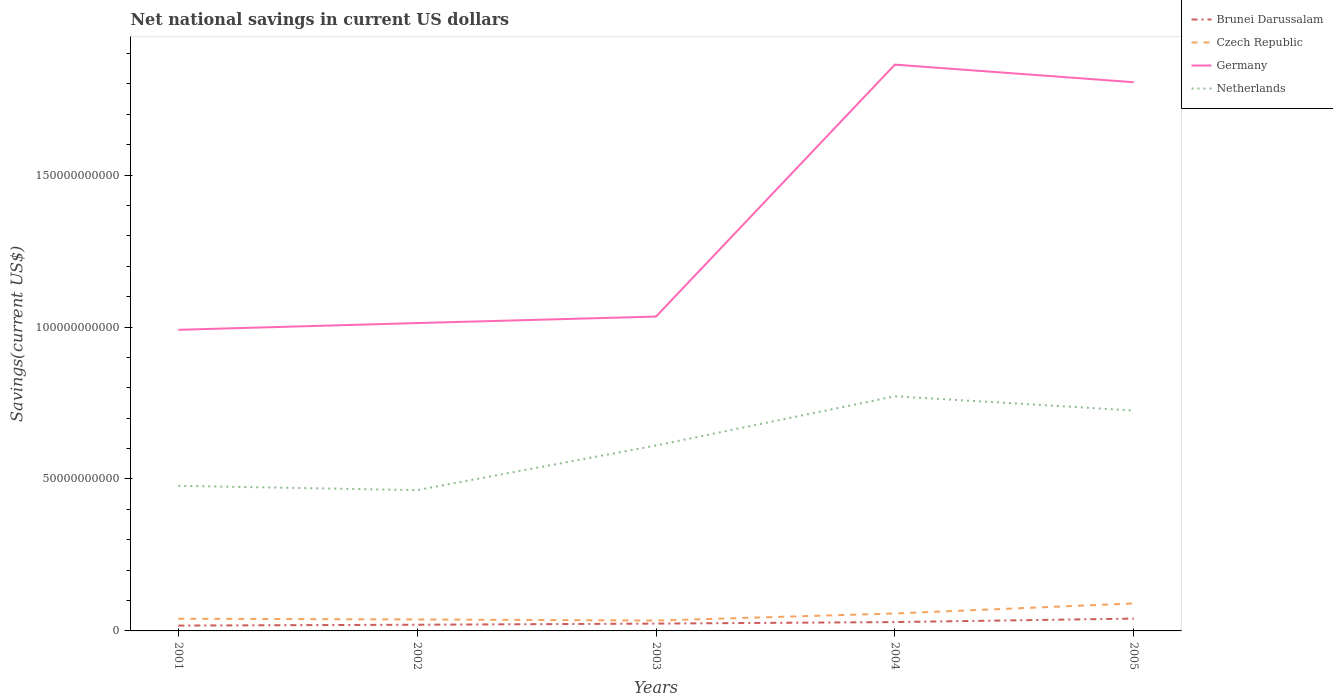Is the number of lines equal to the number of legend labels?
Ensure brevity in your answer.  Yes. Across all years, what is the maximum net national savings in Czech Republic?
Offer a very short reply. 3.42e+09. What is the total net national savings in Czech Republic in the graph?
Provide a short and direct response. 5.85e+08. What is the difference between the highest and the second highest net national savings in Czech Republic?
Keep it short and to the point. 5.63e+09. How many lines are there?
Your answer should be compact. 4. Where does the legend appear in the graph?
Provide a short and direct response. Top right. How are the legend labels stacked?
Your response must be concise. Vertical. What is the title of the graph?
Your answer should be very brief. Net national savings in current US dollars. What is the label or title of the X-axis?
Your answer should be very brief. Years. What is the label or title of the Y-axis?
Make the answer very short. Savings(current US$). What is the Savings(current US$) in Brunei Darussalam in 2001?
Make the answer very short. 1.76e+09. What is the Savings(current US$) of Czech Republic in 2001?
Provide a succinct answer. 4.00e+09. What is the Savings(current US$) of Germany in 2001?
Offer a very short reply. 9.91e+1. What is the Savings(current US$) of Netherlands in 2001?
Keep it short and to the point. 4.77e+1. What is the Savings(current US$) of Brunei Darussalam in 2002?
Provide a short and direct response. 2.04e+09. What is the Savings(current US$) in Czech Republic in 2002?
Make the answer very short. 3.78e+09. What is the Savings(current US$) of Germany in 2002?
Keep it short and to the point. 1.01e+11. What is the Savings(current US$) of Netherlands in 2002?
Offer a terse response. 4.63e+1. What is the Savings(current US$) in Brunei Darussalam in 2003?
Your answer should be compact. 2.41e+09. What is the Savings(current US$) in Czech Republic in 2003?
Offer a terse response. 3.42e+09. What is the Savings(current US$) in Germany in 2003?
Offer a very short reply. 1.03e+11. What is the Savings(current US$) in Netherlands in 2003?
Ensure brevity in your answer.  6.10e+1. What is the Savings(current US$) of Brunei Darussalam in 2004?
Keep it short and to the point. 2.91e+09. What is the Savings(current US$) of Czech Republic in 2004?
Provide a succinct answer. 5.74e+09. What is the Savings(current US$) in Germany in 2004?
Ensure brevity in your answer.  1.86e+11. What is the Savings(current US$) in Netherlands in 2004?
Make the answer very short. 7.72e+1. What is the Savings(current US$) in Brunei Darussalam in 2005?
Your response must be concise. 4.06e+09. What is the Savings(current US$) of Czech Republic in 2005?
Give a very brief answer. 9.04e+09. What is the Savings(current US$) in Germany in 2005?
Make the answer very short. 1.81e+11. What is the Savings(current US$) in Netherlands in 2005?
Give a very brief answer. 7.25e+1. Across all years, what is the maximum Savings(current US$) in Brunei Darussalam?
Keep it short and to the point. 4.06e+09. Across all years, what is the maximum Savings(current US$) in Czech Republic?
Offer a very short reply. 9.04e+09. Across all years, what is the maximum Savings(current US$) of Germany?
Offer a terse response. 1.86e+11. Across all years, what is the maximum Savings(current US$) in Netherlands?
Your answer should be very brief. 7.72e+1. Across all years, what is the minimum Savings(current US$) in Brunei Darussalam?
Make the answer very short. 1.76e+09. Across all years, what is the minimum Savings(current US$) of Czech Republic?
Give a very brief answer. 3.42e+09. Across all years, what is the minimum Savings(current US$) in Germany?
Give a very brief answer. 9.91e+1. Across all years, what is the minimum Savings(current US$) in Netherlands?
Your answer should be compact. 4.63e+1. What is the total Savings(current US$) in Brunei Darussalam in the graph?
Your answer should be compact. 1.32e+1. What is the total Savings(current US$) in Czech Republic in the graph?
Your response must be concise. 2.60e+1. What is the total Savings(current US$) of Germany in the graph?
Your answer should be very brief. 6.71e+11. What is the total Savings(current US$) of Netherlands in the graph?
Keep it short and to the point. 3.05e+11. What is the difference between the Savings(current US$) in Brunei Darussalam in 2001 and that in 2002?
Provide a short and direct response. -2.75e+08. What is the difference between the Savings(current US$) in Czech Republic in 2001 and that in 2002?
Provide a short and direct response. 2.19e+08. What is the difference between the Savings(current US$) of Germany in 2001 and that in 2002?
Your answer should be compact. -2.22e+09. What is the difference between the Savings(current US$) of Netherlands in 2001 and that in 2002?
Your answer should be very brief. 1.41e+09. What is the difference between the Savings(current US$) of Brunei Darussalam in 2001 and that in 2003?
Offer a terse response. -6.52e+08. What is the difference between the Savings(current US$) in Czech Republic in 2001 and that in 2003?
Offer a terse response. 5.85e+08. What is the difference between the Savings(current US$) in Germany in 2001 and that in 2003?
Offer a very short reply. -4.36e+09. What is the difference between the Savings(current US$) of Netherlands in 2001 and that in 2003?
Give a very brief answer. -1.33e+1. What is the difference between the Savings(current US$) in Brunei Darussalam in 2001 and that in 2004?
Your answer should be compact. -1.15e+09. What is the difference between the Savings(current US$) of Czech Republic in 2001 and that in 2004?
Offer a terse response. -1.74e+09. What is the difference between the Savings(current US$) in Germany in 2001 and that in 2004?
Your response must be concise. -8.73e+1. What is the difference between the Savings(current US$) of Netherlands in 2001 and that in 2004?
Your response must be concise. -2.95e+1. What is the difference between the Savings(current US$) in Brunei Darussalam in 2001 and that in 2005?
Provide a succinct answer. -2.30e+09. What is the difference between the Savings(current US$) in Czech Republic in 2001 and that in 2005?
Your response must be concise. -5.04e+09. What is the difference between the Savings(current US$) in Germany in 2001 and that in 2005?
Your answer should be very brief. -8.15e+1. What is the difference between the Savings(current US$) of Netherlands in 2001 and that in 2005?
Make the answer very short. -2.48e+1. What is the difference between the Savings(current US$) in Brunei Darussalam in 2002 and that in 2003?
Give a very brief answer. -3.77e+08. What is the difference between the Savings(current US$) in Czech Republic in 2002 and that in 2003?
Keep it short and to the point. 3.66e+08. What is the difference between the Savings(current US$) in Germany in 2002 and that in 2003?
Give a very brief answer. -2.14e+09. What is the difference between the Savings(current US$) of Netherlands in 2002 and that in 2003?
Offer a very short reply. -1.47e+1. What is the difference between the Savings(current US$) of Brunei Darussalam in 2002 and that in 2004?
Keep it short and to the point. -8.78e+08. What is the difference between the Savings(current US$) of Czech Republic in 2002 and that in 2004?
Offer a terse response. -1.96e+09. What is the difference between the Savings(current US$) in Germany in 2002 and that in 2004?
Keep it short and to the point. -8.50e+1. What is the difference between the Savings(current US$) in Netherlands in 2002 and that in 2004?
Provide a short and direct response. -3.09e+1. What is the difference between the Savings(current US$) in Brunei Darussalam in 2002 and that in 2005?
Offer a very short reply. -2.02e+09. What is the difference between the Savings(current US$) in Czech Republic in 2002 and that in 2005?
Make the answer very short. -5.26e+09. What is the difference between the Savings(current US$) in Germany in 2002 and that in 2005?
Ensure brevity in your answer.  -7.92e+1. What is the difference between the Savings(current US$) of Netherlands in 2002 and that in 2005?
Offer a very short reply. -2.62e+1. What is the difference between the Savings(current US$) of Brunei Darussalam in 2003 and that in 2004?
Provide a succinct answer. -5.01e+08. What is the difference between the Savings(current US$) in Czech Republic in 2003 and that in 2004?
Your answer should be very brief. -2.33e+09. What is the difference between the Savings(current US$) of Germany in 2003 and that in 2004?
Ensure brevity in your answer.  -8.29e+1. What is the difference between the Savings(current US$) of Netherlands in 2003 and that in 2004?
Provide a short and direct response. -1.62e+1. What is the difference between the Savings(current US$) of Brunei Darussalam in 2003 and that in 2005?
Offer a terse response. -1.64e+09. What is the difference between the Savings(current US$) in Czech Republic in 2003 and that in 2005?
Keep it short and to the point. -5.63e+09. What is the difference between the Savings(current US$) in Germany in 2003 and that in 2005?
Provide a short and direct response. -7.71e+1. What is the difference between the Savings(current US$) of Netherlands in 2003 and that in 2005?
Make the answer very short. -1.15e+1. What is the difference between the Savings(current US$) in Brunei Darussalam in 2004 and that in 2005?
Offer a terse response. -1.14e+09. What is the difference between the Savings(current US$) of Czech Republic in 2004 and that in 2005?
Keep it short and to the point. -3.30e+09. What is the difference between the Savings(current US$) in Germany in 2004 and that in 2005?
Your answer should be compact. 5.79e+09. What is the difference between the Savings(current US$) in Netherlands in 2004 and that in 2005?
Give a very brief answer. 4.68e+09. What is the difference between the Savings(current US$) of Brunei Darussalam in 2001 and the Savings(current US$) of Czech Republic in 2002?
Provide a succinct answer. -2.02e+09. What is the difference between the Savings(current US$) in Brunei Darussalam in 2001 and the Savings(current US$) in Germany in 2002?
Keep it short and to the point. -9.95e+1. What is the difference between the Savings(current US$) of Brunei Darussalam in 2001 and the Savings(current US$) of Netherlands in 2002?
Give a very brief answer. -4.46e+1. What is the difference between the Savings(current US$) in Czech Republic in 2001 and the Savings(current US$) in Germany in 2002?
Keep it short and to the point. -9.73e+1. What is the difference between the Savings(current US$) in Czech Republic in 2001 and the Savings(current US$) in Netherlands in 2002?
Ensure brevity in your answer.  -4.23e+1. What is the difference between the Savings(current US$) in Germany in 2001 and the Savings(current US$) in Netherlands in 2002?
Your answer should be compact. 5.27e+1. What is the difference between the Savings(current US$) of Brunei Darussalam in 2001 and the Savings(current US$) of Czech Republic in 2003?
Make the answer very short. -1.66e+09. What is the difference between the Savings(current US$) of Brunei Darussalam in 2001 and the Savings(current US$) of Germany in 2003?
Make the answer very short. -1.02e+11. What is the difference between the Savings(current US$) of Brunei Darussalam in 2001 and the Savings(current US$) of Netherlands in 2003?
Your answer should be compact. -5.92e+1. What is the difference between the Savings(current US$) of Czech Republic in 2001 and the Savings(current US$) of Germany in 2003?
Offer a very short reply. -9.94e+1. What is the difference between the Savings(current US$) in Czech Republic in 2001 and the Savings(current US$) in Netherlands in 2003?
Your answer should be compact. -5.70e+1. What is the difference between the Savings(current US$) of Germany in 2001 and the Savings(current US$) of Netherlands in 2003?
Keep it short and to the point. 3.81e+1. What is the difference between the Savings(current US$) of Brunei Darussalam in 2001 and the Savings(current US$) of Czech Republic in 2004?
Give a very brief answer. -3.98e+09. What is the difference between the Savings(current US$) of Brunei Darussalam in 2001 and the Savings(current US$) of Germany in 2004?
Ensure brevity in your answer.  -1.85e+11. What is the difference between the Savings(current US$) in Brunei Darussalam in 2001 and the Savings(current US$) in Netherlands in 2004?
Provide a succinct answer. -7.54e+1. What is the difference between the Savings(current US$) in Czech Republic in 2001 and the Savings(current US$) in Germany in 2004?
Make the answer very short. -1.82e+11. What is the difference between the Savings(current US$) in Czech Republic in 2001 and the Savings(current US$) in Netherlands in 2004?
Your answer should be compact. -7.32e+1. What is the difference between the Savings(current US$) of Germany in 2001 and the Savings(current US$) of Netherlands in 2004?
Provide a short and direct response. 2.19e+1. What is the difference between the Savings(current US$) in Brunei Darussalam in 2001 and the Savings(current US$) in Czech Republic in 2005?
Ensure brevity in your answer.  -7.28e+09. What is the difference between the Savings(current US$) in Brunei Darussalam in 2001 and the Savings(current US$) in Germany in 2005?
Offer a very short reply. -1.79e+11. What is the difference between the Savings(current US$) of Brunei Darussalam in 2001 and the Savings(current US$) of Netherlands in 2005?
Provide a succinct answer. -7.08e+1. What is the difference between the Savings(current US$) in Czech Republic in 2001 and the Savings(current US$) in Germany in 2005?
Ensure brevity in your answer.  -1.77e+11. What is the difference between the Savings(current US$) in Czech Republic in 2001 and the Savings(current US$) in Netherlands in 2005?
Make the answer very short. -6.85e+1. What is the difference between the Savings(current US$) of Germany in 2001 and the Savings(current US$) of Netherlands in 2005?
Make the answer very short. 2.66e+1. What is the difference between the Savings(current US$) of Brunei Darussalam in 2002 and the Savings(current US$) of Czech Republic in 2003?
Ensure brevity in your answer.  -1.38e+09. What is the difference between the Savings(current US$) in Brunei Darussalam in 2002 and the Savings(current US$) in Germany in 2003?
Keep it short and to the point. -1.01e+11. What is the difference between the Savings(current US$) of Brunei Darussalam in 2002 and the Savings(current US$) of Netherlands in 2003?
Your response must be concise. -5.90e+1. What is the difference between the Savings(current US$) of Czech Republic in 2002 and the Savings(current US$) of Germany in 2003?
Keep it short and to the point. -9.97e+1. What is the difference between the Savings(current US$) of Czech Republic in 2002 and the Savings(current US$) of Netherlands in 2003?
Your answer should be very brief. -5.72e+1. What is the difference between the Savings(current US$) in Germany in 2002 and the Savings(current US$) in Netherlands in 2003?
Offer a terse response. 4.03e+1. What is the difference between the Savings(current US$) of Brunei Darussalam in 2002 and the Savings(current US$) of Czech Republic in 2004?
Make the answer very short. -3.71e+09. What is the difference between the Savings(current US$) in Brunei Darussalam in 2002 and the Savings(current US$) in Germany in 2004?
Offer a very short reply. -1.84e+11. What is the difference between the Savings(current US$) of Brunei Darussalam in 2002 and the Savings(current US$) of Netherlands in 2004?
Your answer should be very brief. -7.52e+1. What is the difference between the Savings(current US$) of Czech Republic in 2002 and the Savings(current US$) of Germany in 2004?
Your answer should be very brief. -1.83e+11. What is the difference between the Savings(current US$) of Czech Republic in 2002 and the Savings(current US$) of Netherlands in 2004?
Keep it short and to the point. -7.34e+1. What is the difference between the Savings(current US$) in Germany in 2002 and the Savings(current US$) in Netherlands in 2004?
Your answer should be very brief. 2.41e+1. What is the difference between the Savings(current US$) of Brunei Darussalam in 2002 and the Savings(current US$) of Czech Republic in 2005?
Offer a very short reply. -7.01e+09. What is the difference between the Savings(current US$) of Brunei Darussalam in 2002 and the Savings(current US$) of Germany in 2005?
Offer a very short reply. -1.79e+11. What is the difference between the Savings(current US$) of Brunei Darussalam in 2002 and the Savings(current US$) of Netherlands in 2005?
Your response must be concise. -7.05e+1. What is the difference between the Savings(current US$) in Czech Republic in 2002 and the Savings(current US$) in Germany in 2005?
Offer a very short reply. -1.77e+11. What is the difference between the Savings(current US$) in Czech Republic in 2002 and the Savings(current US$) in Netherlands in 2005?
Make the answer very short. -6.87e+1. What is the difference between the Savings(current US$) in Germany in 2002 and the Savings(current US$) in Netherlands in 2005?
Offer a terse response. 2.88e+1. What is the difference between the Savings(current US$) of Brunei Darussalam in 2003 and the Savings(current US$) of Czech Republic in 2004?
Your answer should be very brief. -3.33e+09. What is the difference between the Savings(current US$) of Brunei Darussalam in 2003 and the Savings(current US$) of Germany in 2004?
Provide a short and direct response. -1.84e+11. What is the difference between the Savings(current US$) in Brunei Darussalam in 2003 and the Savings(current US$) in Netherlands in 2004?
Give a very brief answer. -7.48e+1. What is the difference between the Savings(current US$) in Czech Republic in 2003 and the Savings(current US$) in Germany in 2004?
Your answer should be very brief. -1.83e+11. What is the difference between the Savings(current US$) in Czech Republic in 2003 and the Savings(current US$) in Netherlands in 2004?
Your response must be concise. -7.38e+1. What is the difference between the Savings(current US$) in Germany in 2003 and the Savings(current US$) in Netherlands in 2004?
Offer a very short reply. 2.62e+1. What is the difference between the Savings(current US$) of Brunei Darussalam in 2003 and the Savings(current US$) of Czech Republic in 2005?
Your answer should be compact. -6.63e+09. What is the difference between the Savings(current US$) in Brunei Darussalam in 2003 and the Savings(current US$) in Germany in 2005?
Provide a short and direct response. -1.78e+11. What is the difference between the Savings(current US$) of Brunei Darussalam in 2003 and the Savings(current US$) of Netherlands in 2005?
Keep it short and to the point. -7.01e+1. What is the difference between the Savings(current US$) of Czech Republic in 2003 and the Savings(current US$) of Germany in 2005?
Provide a short and direct response. -1.77e+11. What is the difference between the Savings(current US$) of Czech Republic in 2003 and the Savings(current US$) of Netherlands in 2005?
Your answer should be very brief. -6.91e+1. What is the difference between the Savings(current US$) of Germany in 2003 and the Savings(current US$) of Netherlands in 2005?
Offer a terse response. 3.09e+1. What is the difference between the Savings(current US$) in Brunei Darussalam in 2004 and the Savings(current US$) in Czech Republic in 2005?
Provide a short and direct response. -6.13e+09. What is the difference between the Savings(current US$) in Brunei Darussalam in 2004 and the Savings(current US$) in Germany in 2005?
Make the answer very short. -1.78e+11. What is the difference between the Savings(current US$) in Brunei Darussalam in 2004 and the Savings(current US$) in Netherlands in 2005?
Give a very brief answer. -6.96e+1. What is the difference between the Savings(current US$) of Czech Republic in 2004 and the Savings(current US$) of Germany in 2005?
Make the answer very short. -1.75e+11. What is the difference between the Savings(current US$) of Czech Republic in 2004 and the Savings(current US$) of Netherlands in 2005?
Your response must be concise. -6.68e+1. What is the difference between the Savings(current US$) in Germany in 2004 and the Savings(current US$) in Netherlands in 2005?
Provide a succinct answer. 1.14e+11. What is the average Savings(current US$) in Brunei Darussalam per year?
Your answer should be compact. 2.64e+09. What is the average Savings(current US$) of Czech Republic per year?
Keep it short and to the point. 5.20e+09. What is the average Savings(current US$) of Germany per year?
Keep it short and to the point. 1.34e+11. What is the average Savings(current US$) of Netherlands per year?
Keep it short and to the point. 6.10e+1. In the year 2001, what is the difference between the Savings(current US$) in Brunei Darussalam and Savings(current US$) in Czech Republic?
Offer a terse response. -2.24e+09. In the year 2001, what is the difference between the Savings(current US$) in Brunei Darussalam and Savings(current US$) in Germany?
Your answer should be very brief. -9.73e+1. In the year 2001, what is the difference between the Savings(current US$) of Brunei Darussalam and Savings(current US$) of Netherlands?
Your answer should be very brief. -4.60e+1. In the year 2001, what is the difference between the Savings(current US$) of Czech Republic and Savings(current US$) of Germany?
Your answer should be compact. -9.51e+1. In the year 2001, what is the difference between the Savings(current US$) of Czech Republic and Savings(current US$) of Netherlands?
Provide a succinct answer. -4.37e+1. In the year 2001, what is the difference between the Savings(current US$) of Germany and Savings(current US$) of Netherlands?
Your answer should be compact. 5.13e+1. In the year 2002, what is the difference between the Savings(current US$) of Brunei Darussalam and Savings(current US$) of Czech Republic?
Your answer should be very brief. -1.75e+09. In the year 2002, what is the difference between the Savings(current US$) of Brunei Darussalam and Savings(current US$) of Germany?
Offer a very short reply. -9.93e+1. In the year 2002, what is the difference between the Savings(current US$) of Brunei Darussalam and Savings(current US$) of Netherlands?
Your response must be concise. -4.43e+1. In the year 2002, what is the difference between the Savings(current US$) in Czech Republic and Savings(current US$) in Germany?
Offer a terse response. -9.75e+1. In the year 2002, what is the difference between the Savings(current US$) in Czech Republic and Savings(current US$) in Netherlands?
Make the answer very short. -4.25e+1. In the year 2002, what is the difference between the Savings(current US$) in Germany and Savings(current US$) in Netherlands?
Ensure brevity in your answer.  5.50e+1. In the year 2003, what is the difference between the Savings(current US$) in Brunei Darussalam and Savings(current US$) in Czech Republic?
Provide a succinct answer. -1.00e+09. In the year 2003, what is the difference between the Savings(current US$) of Brunei Darussalam and Savings(current US$) of Germany?
Offer a very short reply. -1.01e+11. In the year 2003, what is the difference between the Savings(current US$) of Brunei Darussalam and Savings(current US$) of Netherlands?
Make the answer very short. -5.86e+1. In the year 2003, what is the difference between the Savings(current US$) of Czech Republic and Savings(current US$) of Germany?
Make the answer very short. -1.00e+11. In the year 2003, what is the difference between the Savings(current US$) in Czech Republic and Savings(current US$) in Netherlands?
Keep it short and to the point. -5.76e+1. In the year 2003, what is the difference between the Savings(current US$) in Germany and Savings(current US$) in Netherlands?
Your answer should be very brief. 4.24e+1. In the year 2004, what is the difference between the Savings(current US$) of Brunei Darussalam and Savings(current US$) of Czech Republic?
Give a very brief answer. -2.83e+09. In the year 2004, what is the difference between the Savings(current US$) in Brunei Darussalam and Savings(current US$) in Germany?
Your answer should be compact. -1.83e+11. In the year 2004, what is the difference between the Savings(current US$) of Brunei Darussalam and Savings(current US$) of Netherlands?
Make the answer very short. -7.43e+1. In the year 2004, what is the difference between the Savings(current US$) of Czech Republic and Savings(current US$) of Germany?
Provide a short and direct response. -1.81e+11. In the year 2004, what is the difference between the Savings(current US$) of Czech Republic and Savings(current US$) of Netherlands?
Offer a terse response. -7.15e+1. In the year 2004, what is the difference between the Savings(current US$) in Germany and Savings(current US$) in Netherlands?
Keep it short and to the point. 1.09e+11. In the year 2005, what is the difference between the Savings(current US$) in Brunei Darussalam and Savings(current US$) in Czech Republic?
Provide a short and direct response. -4.99e+09. In the year 2005, what is the difference between the Savings(current US$) in Brunei Darussalam and Savings(current US$) in Germany?
Make the answer very short. -1.76e+11. In the year 2005, what is the difference between the Savings(current US$) in Brunei Darussalam and Savings(current US$) in Netherlands?
Offer a very short reply. -6.85e+1. In the year 2005, what is the difference between the Savings(current US$) of Czech Republic and Savings(current US$) of Germany?
Ensure brevity in your answer.  -1.71e+11. In the year 2005, what is the difference between the Savings(current US$) of Czech Republic and Savings(current US$) of Netherlands?
Make the answer very short. -6.35e+1. In the year 2005, what is the difference between the Savings(current US$) in Germany and Savings(current US$) in Netherlands?
Give a very brief answer. 1.08e+11. What is the ratio of the Savings(current US$) of Brunei Darussalam in 2001 to that in 2002?
Provide a succinct answer. 0.86. What is the ratio of the Savings(current US$) in Czech Republic in 2001 to that in 2002?
Provide a short and direct response. 1.06. What is the ratio of the Savings(current US$) in Germany in 2001 to that in 2002?
Ensure brevity in your answer.  0.98. What is the ratio of the Savings(current US$) of Netherlands in 2001 to that in 2002?
Your response must be concise. 1.03. What is the ratio of the Savings(current US$) in Brunei Darussalam in 2001 to that in 2003?
Ensure brevity in your answer.  0.73. What is the ratio of the Savings(current US$) in Czech Republic in 2001 to that in 2003?
Offer a very short reply. 1.17. What is the ratio of the Savings(current US$) in Germany in 2001 to that in 2003?
Your answer should be very brief. 0.96. What is the ratio of the Savings(current US$) of Netherlands in 2001 to that in 2003?
Your response must be concise. 0.78. What is the ratio of the Savings(current US$) in Brunei Darussalam in 2001 to that in 2004?
Your answer should be very brief. 0.6. What is the ratio of the Savings(current US$) in Czech Republic in 2001 to that in 2004?
Offer a terse response. 0.7. What is the ratio of the Savings(current US$) in Germany in 2001 to that in 2004?
Keep it short and to the point. 0.53. What is the ratio of the Savings(current US$) of Netherlands in 2001 to that in 2004?
Offer a terse response. 0.62. What is the ratio of the Savings(current US$) of Brunei Darussalam in 2001 to that in 2005?
Your answer should be compact. 0.43. What is the ratio of the Savings(current US$) in Czech Republic in 2001 to that in 2005?
Offer a very short reply. 0.44. What is the ratio of the Savings(current US$) in Germany in 2001 to that in 2005?
Your response must be concise. 0.55. What is the ratio of the Savings(current US$) in Netherlands in 2001 to that in 2005?
Your response must be concise. 0.66. What is the ratio of the Savings(current US$) in Brunei Darussalam in 2002 to that in 2003?
Your answer should be very brief. 0.84. What is the ratio of the Savings(current US$) of Czech Republic in 2002 to that in 2003?
Keep it short and to the point. 1.11. What is the ratio of the Savings(current US$) in Germany in 2002 to that in 2003?
Offer a terse response. 0.98. What is the ratio of the Savings(current US$) in Netherlands in 2002 to that in 2003?
Give a very brief answer. 0.76. What is the ratio of the Savings(current US$) in Brunei Darussalam in 2002 to that in 2004?
Your response must be concise. 0.7. What is the ratio of the Savings(current US$) in Czech Republic in 2002 to that in 2004?
Your answer should be compact. 0.66. What is the ratio of the Savings(current US$) of Germany in 2002 to that in 2004?
Make the answer very short. 0.54. What is the ratio of the Savings(current US$) of Netherlands in 2002 to that in 2004?
Provide a succinct answer. 0.6. What is the ratio of the Savings(current US$) of Brunei Darussalam in 2002 to that in 2005?
Ensure brevity in your answer.  0.5. What is the ratio of the Savings(current US$) in Czech Republic in 2002 to that in 2005?
Provide a succinct answer. 0.42. What is the ratio of the Savings(current US$) in Germany in 2002 to that in 2005?
Your answer should be compact. 0.56. What is the ratio of the Savings(current US$) in Netherlands in 2002 to that in 2005?
Provide a short and direct response. 0.64. What is the ratio of the Savings(current US$) of Brunei Darussalam in 2003 to that in 2004?
Provide a short and direct response. 0.83. What is the ratio of the Savings(current US$) of Czech Republic in 2003 to that in 2004?
Provide a short and direct response. 0.59. What is the ratio of the Savings(current US$) in Germany in 2003 to that in 2004?
Give a very brief answer. 0.56. What is the ratio of the Savings(current US$) of Netherlands in 2003 to that in 2004?
Offer a very short reply. 0.79. What is the ratio of the Savings(current US$) in Brunei Darussalam in 2003 to that in 2005?
Offer a terse response. 0.59. What is the ratio of the Savings(current US$) of Czech Republic in 2003 to that in 2005?
Keep it short and to the point. 0.38. What is the ratio of the Savings(current US$) in Germany in 2003 to that in 2005?
Give a very brief answer. 0.57. What is the ratio of the Savings(current US$) of Netherlands in 2003 to that in 2005?
Your answer should be very brief. 0.84. What is the ratio of the Savings(current US$) in Brunei Darussalam in 2004 to that in 2005?
Offer a very short reply. 0.72. What is the ratio of the Savings(current US$) in Czech Republic in 2004 to that in 2005?
Your answer should be very brief. 0.64. What is the ratio of the Savings(current US$) of Germany in 2004 to that in 2005?
Your response must be concise. 1.03. What is the ratio of the Savings(current US$) of Netherlands in 2004 to that in 2005?
Give a very brief answer. 1.06. What is the difference between the highest and the second highest Savings(current US$) in Brunei Darussalam?
Your answer should be compact. 1.14e+09. What is the difference between the highest and the second highest Savings(current US$) of Czech Republic?
Your response must be concise. 3.30e+09. What is the difference between the highest and the second highest Savings(current US$) in Germany?
Your answer should be very brief. 5.79e+09. What is the difference between the highest and the second highest Savings(current US$) of Netherlands?
Keep it short and to the point. 4.68e+09. What is the difference between the highest and the lowest Savings(current US$) in Brunei Darussalam?
Ensure brevity in your answer.  2.30e+09. What is the difference between the highest and the lowest Savings(current US$) of Czech Republic?
Make the answer very short. 5.63e+09. What is the difference between the highest and the lowest Savings(current US$) of Germany?
Keep it short and to the point. 8.73e+1. What is the difference between the highest and the lowest Savings(current US$) in Netherlands?
Your response must be concise. 3.09e+1. 